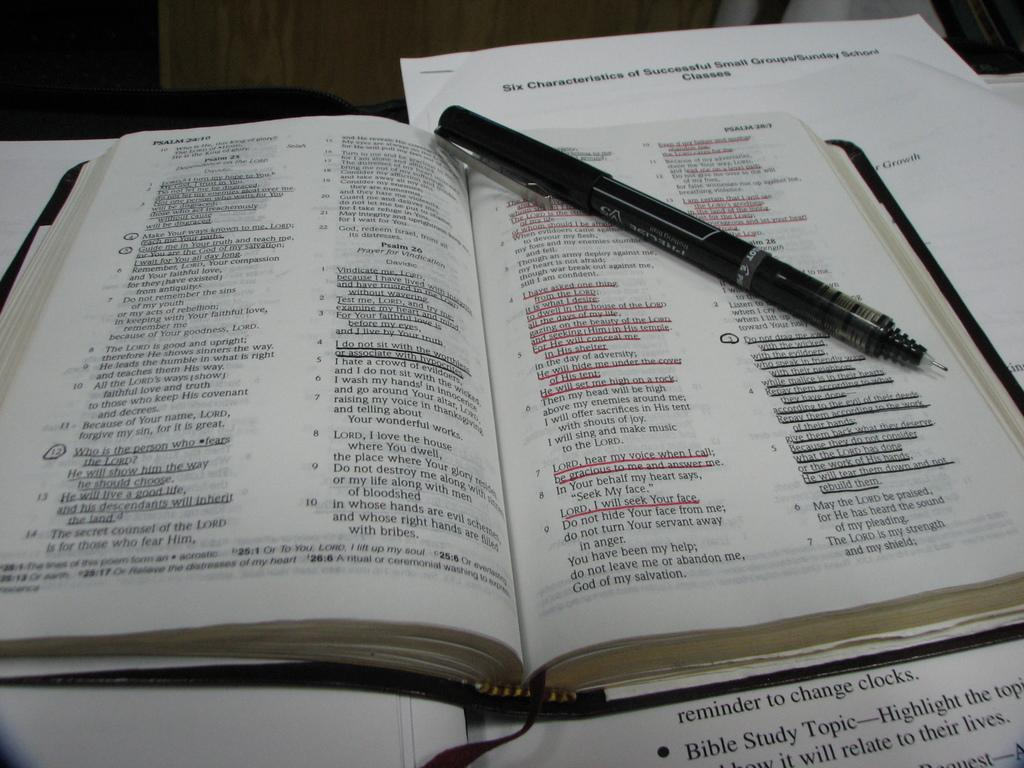What is the main object in the image? There is an open book in the image. What is placed on the open book? There is a pen on the open book. What is located under the open book? There is a paper under the open book. What is the person's opinion on the force of gravity in the image? There is no person or any reference to opinions or the force of gravity in the image. 